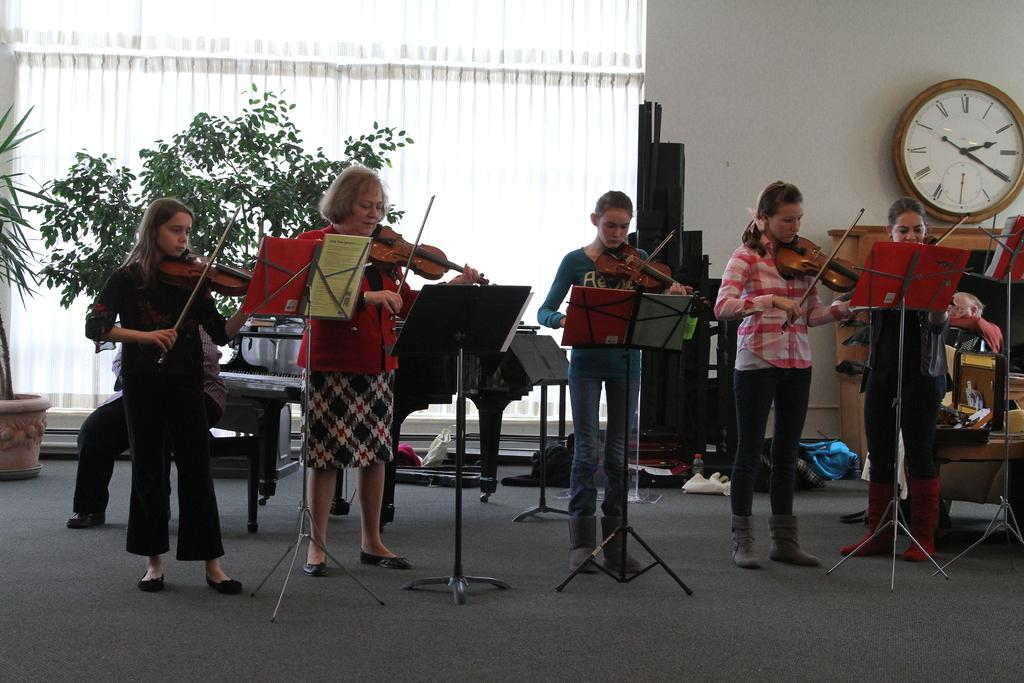What are the people in the image doing? There is a group of people playing violins in the image. What objects are in front of the people playing violins? There are book stands in front of the people. What time-telling device can be seen on the wall? There is a wall clock on the wall. What type of vegetation is visible in the image? There are plants visible in the image. What type of trousers are the people wearing while playing the violins? There is no information about the type of trousers the people are wearing in the image. Can you see a hat on any of the people playing the violins? There is no hat visible on any of the people playing the violins in the image. 